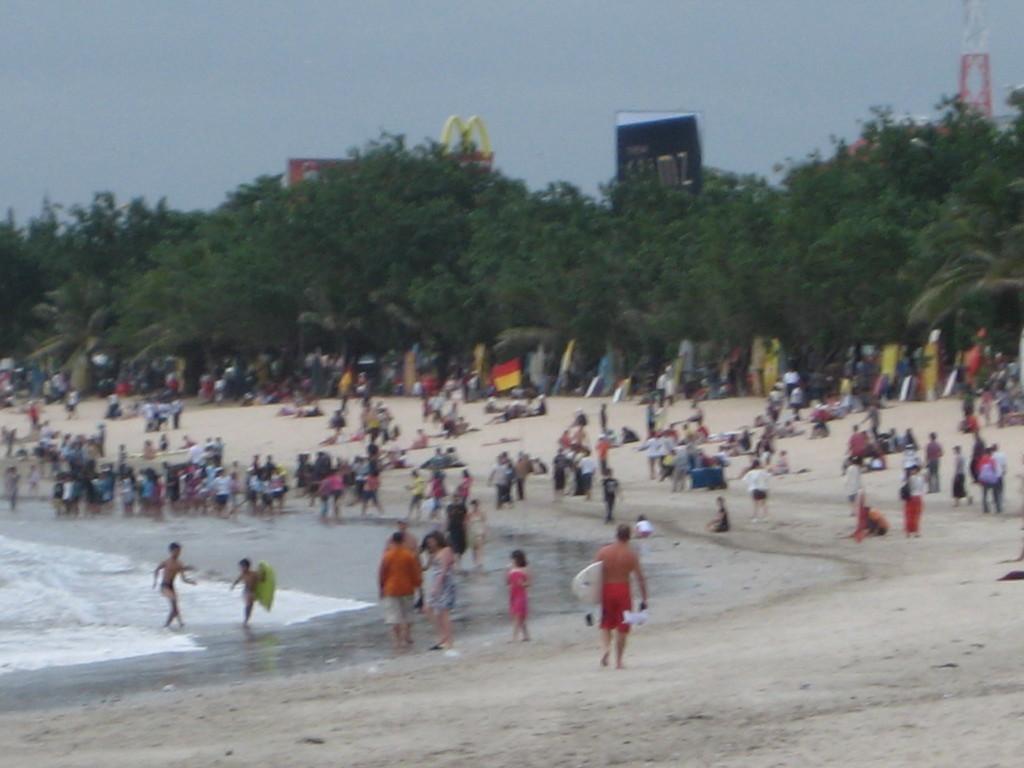In one or two sentences, can you explain what this image depicts? In this picture there is a man who is wearing short and holding the ski board. On the left I can see many peoples were standing on the beach and some peoples were sitting. In the background I can see the trees, banners, building and posters. At the bottom I can see the sand. 